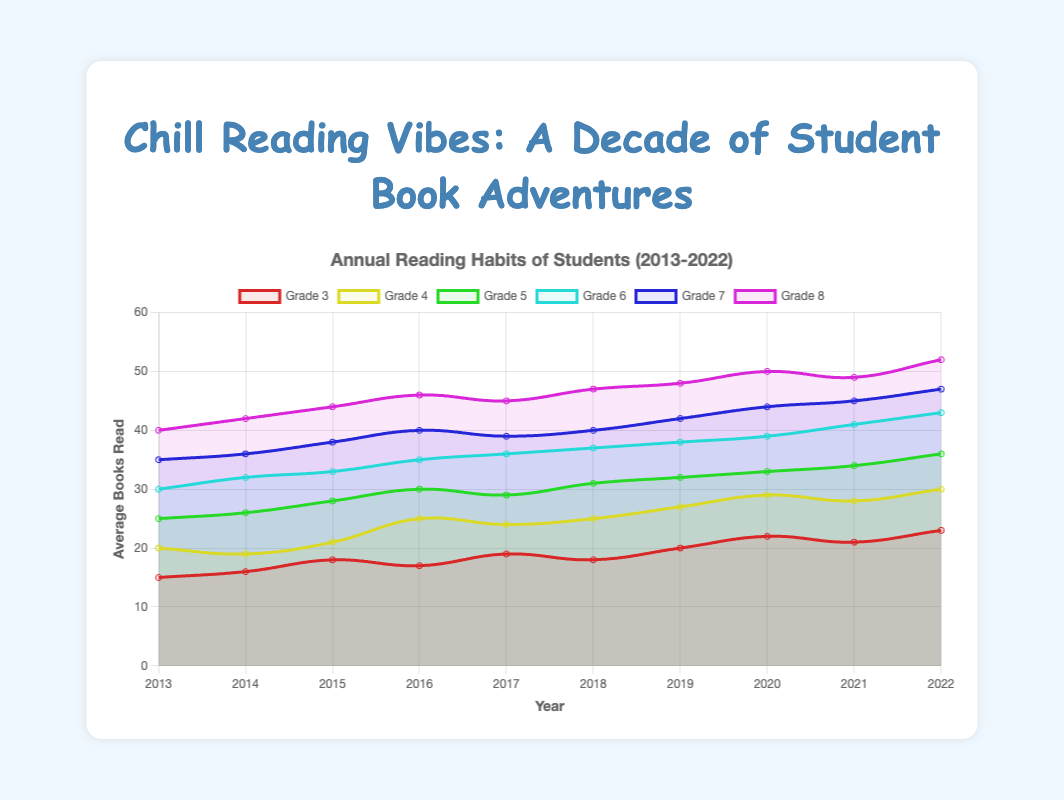Which grade read the most books in 2022? To find this, look at the last data point (2022) for each grade on the plot. The number of books for each grade in 2022 are: Grade 3: 23, Grade 4: 30, Grade 5: 36, Grade 6: 43, Grade 7: 47, Grade 8: 52. Grade 8 has the highest number, which is 52.
Answer: Grade 8 How did the number of books read by Grade 5 change from 2017 to 2018? First, check the values for Grade 5 in 2017 and 2018. They read 29 books in 2017 and 31 books in 2018. The difference between these two values is 31 - 29 = 2.
Answer: Increased by 2 Which grade had the largest increase in average books read from 2020 to 2021? Inspect the changes for each grade between 2020 and 2021. The increases are: Grade 3: 22 to 21 (-1), Grade 4: 29 to 28 (-1), Grade 5: 33 to 34 (1), Grade 6: 39 to 41 (2), Grade 7: 44 to 45 (1), Grade 8: 50 to 49 (-1). Grade 6 had the largest increase, which is 2 books.
Answer: Grade 6 How many more books did Grade 6 read on average in 2022 compared to 2013? Find the values for Grade 6 in 2022 and 2013. They read 43 books in 2022 and 30 books in 2013. The difference is 43 - 30 = 13.
Answer: 13 Which line is the steepest between 2013 and 2022? The steepness of each line corresponds to the overall increase from 2013 to 2022 for each grade. The differences are: Grade 3: 23 - 15 = 8, Grade 4: 30 - 20 = 10, Grade 5: 36 - 25 = 11, Grade 6: 43 - 30 = 13, Grade 7: 47 - 35 = 12, Grade 8: 52 - 40 = 12. Grade 6 has the steepest line with an increase of 13 books.
Answer: Grade 6 What's the average number of books read by Grade 8 between 2013 and 2022? Add the number of books for Grade 8 for all years and divide by the number of years. (40 + 42 + 44 + 46 + 45 + 47 + 48 + 50 + 49 + 52) / 10 = 463 / 10 = 46.3.
Answer: 46.3 Compare the number of books read by Grade 3 and Grade 4 in 2016. Which grade read more? Check the values for both grades in 2016. Grade 3 read 17 books, whereas Grade 4 read 25 books. Grade 4 read more books.
Answer: Grade 4 What is the trend in the number of books read by Grade 7 from 2017 to 2018? Look at the points for Grade 7 in 2017 and 2018. They read 39 books in 2017 and 40 books in 2018. The trend shows a slight increase.
Answer: Increase What was the largest number of books read by any grade in any year? Observe all data points. The highest number is 52, read by Grade 8 in 2022.
Answer: 52 